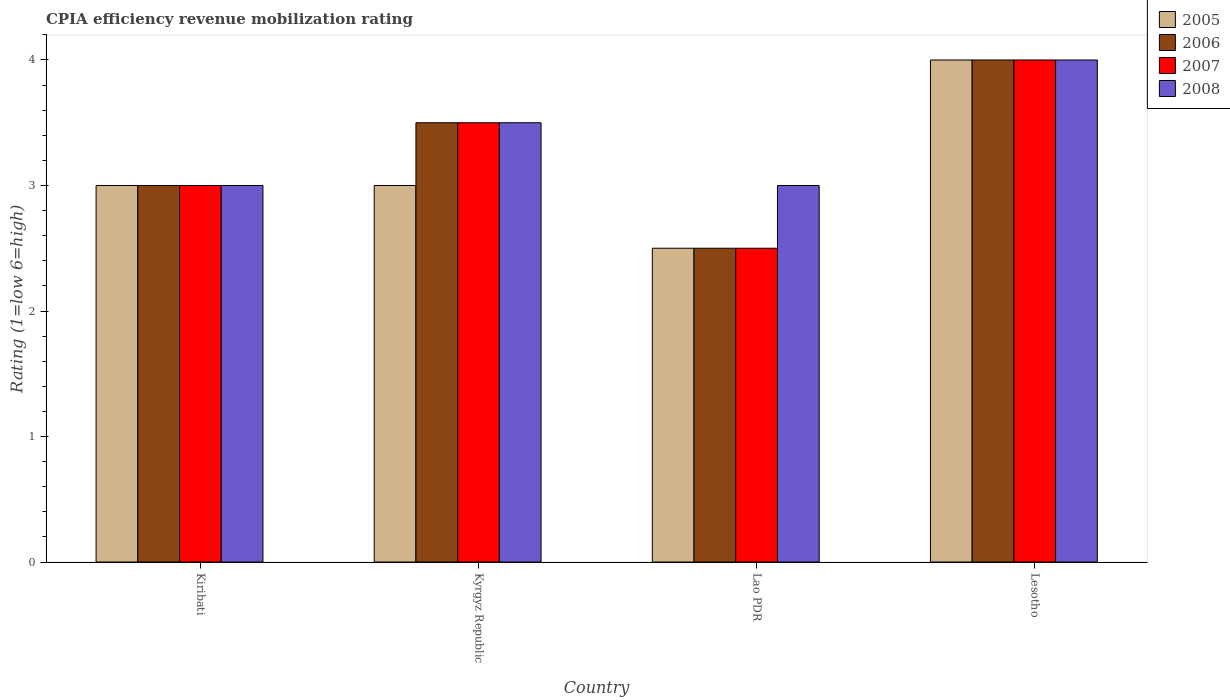How many different coloured bars are there?
Make the answer very short. 4. How many bars are there on the 1st tick from the right?
Your response must be concise. 4. What is the label of the 3rd group of bars from the left?
Provide a short and direct response. Lao PDR. In how many cases, is the number of bars for a given country not equal to the number of legend labels?
Offer a very short reply. 0. Across all countries, what is the maximum CPIA rating in 2007?
Your answer should be compact. 4. In which country was the CPIA rating in 2008 maximum?
Make the answer very short. Lesotho. In which country was the CPIA rating in 2008 minimum?
Your response must be concise. Kiribati. What is the difference between the CPIA rating in 2007 in Lao PDR and that in Lesotho?
Offer a very short reply. -1.5. What is the difference between the CPIA rating in 2008 in Kyrgyz Republic and the CPIA rating in 2006 in Lao PDR?
Ensure brevity in your answer.  1. What is the average CPIA rating in 2008 per country?
Provide a succinct answer. 3.38. What is the difference between the CPIA rating of/in 2005 and CPIA rating of/in 2008 in Lao PDR?
Provide a short and direct response. -0.5. Is the difference between the CPIA rating in 2005 in Kiribati and Lesotho greater than the difference between the CPIA rating in 2008 in Kiribati and Lesotho?
Offer a very short reply. No. What is the difference between the highest and the lowest CPIA rating in 2008?
Provide a succinct answer. 1. Is the sum of the CPIA rating in 2008 in Lao PDR and Lesotho greater than the maximum CPIA rating in 2006 across all countries?
Your answer should be compact. Yes. How many countries are there in the graph?
Your response must be concise. 4. What is the difference between two consecutive major ticks on the Y-axis?
Your response must be concise. 1. Are the values on the major ticks of Y-axis written in scientific E-notation?
Offer a very short reply. No. Does the graph contain any zero values?
Provide a short and direct response. No. Does the graph contain grids?
Provide a short and direct response. No. Where does the legend appear in the graph?
Make the answer very short. Top right. What is the title of the graph?
Your response must be concise. CPIA efficiency revenue mobilization rating. What is the label or title of the X-axis?
Provide a succinct answer. Country. What is the label or title of the Y-axis?
Your response must be concise. Rating (1=low 6=high). What is the Rating (1=low 6=high) of 2005 in Kiribati?
Your response must be concise. 3. What is the Rating (1=low 6=high) of 2006 in Kiribati?
Ensure brevity in your answer.  3. What is the Rating (1=low 6=high) of 2005 in Kyrgyz Republic?
Provide a short and direct response. 3. What is the Rating (1=low 6=high) in 2007 in Kyrgyz Republic?
Give a very brief answer. 3.5. What is the Rating (1=low 6=high) of 2008 in Kyrgyz Republic?
Keep it short and to the point. 3.5. What is the Rating (1=low 6=high) in 2006 in Lao PDR?
Your answer should be compact. 2.5. What is the Rating (1=low 6=high) of 2006 in Lesotho?
Your answer should be compact. 4. What is the Rating (1=low 6=high) in 2008 in Lesotho?
Make the answer very short. 4. Across all countries, what is the maximum Rating (1=low 6=high) in 2007?
Your response must be concise. 4. Across all countries, what is the maximum Rating (1=low 6=high) of 2008?
Your answer should be very brief. 4. Across all countries, what is the minimum Rating (1=low 6=high) in 2007?
Make the answer very short. 2.5. What is the total Rating (1=low 6=high) in 2006 in the graph?
Make the answer very short. 13. What is the total Rating (1=low 6=high) in 2008 in the graph?
Your answer should be very brief. 13.5. What is the difference between the Rating (1=low 6=high) of 2005 in Kiribati and that in Kyrgyz Republic?
Provide a short and direct response. 0. What is the difference between the Rating (1=low 6=high) of 2006 in Kiribati and that in Kyrgyz Republic?
Offer a terse response. -0.5. What is the difference between the Rating (1=low 6=high) in 2007 in Kiribati and that in Kyrgyz Republic?
Provide a short and direct response. -0.5. What is the difference between the Rating (1=low 6=high) of 2008 in Kiribati and that in Kyrgyz Republic?
Ensure brevity in your answer.  -0.5. What is the difference between the Rating (1=low 6=high) of 2006 in Kiribati and that in Lao PDR?
Ensure brevity in your answer.  0.5. What is the difference between the Rating (1=low 6=high) of 2008 in Kiribati and that in Lao PDR?
Your answer should be very brief. 0. What is the difference between the Rating (1=low 6=high) in 2007 in Kiribati and that in Lesotho?
Provide a short and direct response. -1. What is the difference between the Rating (1=low 6=high) of 2007 in Lao PDR and that in Lesotho?
Offer a very short reply. -1.5. What is the difference between the Rating (1=low 6=high) of 2008 in Lao PDR and that in Lesotho?
Offer a very short reply. -1. What is the difference between the Rating (1=low 6=high) of 2005 in Kiribati and the Rating (1=low 6=high) of 2006 in Kyrgyz Republic?
Provide a short and direct response. -0.5. What is the difference between the Rating (1=low 6=high) of 2006 in Kiribati and the Rating (1=low 6=high) of 2008 in Lao PDR?
Your response must be concise. 0. What is the difference between the Rating (1=low 6=high) of 2005 in Kiribati and the Rating (1=low 6=high) of 2007 in Lesotho?
Offer a very short reply. -1. What is the difference between the Rating (1=low 6=high) of 2005 in Kiribati and the Rating (1=low 6=high) of 2008 in Lesotho?
Your answer should be very brief. -1. What is the difference between the Rating (1=low 6=high) of 2006 in Kiribati and the Rating (1=low 6=high) of 2008 in Lesotho?
Ensure brevity in your answer.  -1. What is the difference between the Rating (1=low 6=high) of 2007 in Kiribati and the Rating (1=low 6=high) of 2008 in Lesotho?
Ensure brevity in your answer.  -1. What is the difference between the Rating (1=low 6=high) in 2005 in Kyrgyz Republic and the Rating (1=low 6=high) in 2006 in Lao PDR?
Offer a very short reply. 0.5. What is the difference between the Rating (1=low 6=high) of 2006 in Kyrgyz Republic and the Rating (1=low 6=high) of 2007 in Lao PDR?
Your response must be concise. 1. What is the difference between the Rating (1=low 6=high) in 2006 in Kyrgyz Republic and the Rating (1=low 6=high) in 2008 in Lao PDR?
Your response must be concise. 0.5. What is the difference between the Rating (1=low 6=high) of 2007 in Kyrgyz Republic and the Rating (1=low 6=high) of 2008 in Lao PDR?
Keep it short and to the point. 0.5. What is the difference between the Rating (1=low 6=high) in 2005 in Kyrgyz Republic and the Rating (1=low 6=high) in 2006 in Lesotho?
Offer a terse response. -1. What is the difference between the Rating (1=low 6=high) in 2007 in Kyrgyz Republic and the Rating (1=low 6=high) in 2008 in Lesotho?
Provide a short and direct response. -0.5. What is the difference between the Rating (1=low 6=high) in 2006 in Lao PDR and the Rating (1=low 6=high) in 2008 in Lesotho?
Offer a terse response. -1.5. What is the average Rating (1=low 6=high) in 2005 per country?
Your answer should be compact. 3.12. What is the average Rating (1=low 6=high) of 2006 per country?
Your answer should be compact. 3.25. What is the average Rating (1=low 6=high) in 2008 per country?
Your answer should be very brief. 3.38. What is the difference between the Rating (1=low 6=high) of 2005 and Rating (1=low 6=high) of 2006 in Kiribati?
Give a very brief answer. 0. What is the difference between the Rating (1=low 6=high) of 2005 and Rating (1=low 6=high) of 2007 in Kiribati?
Offer a terse response. 0. What is the difference between the Rating (1=low 6=high) of 2006 and Rating (1=low 6=high) of 2007 in Kiribati?
Your answer should be compact. 0. What is the difference between the Rating (1=low 6=high) in 2007 and Rating (1=low 6=high) in 2008 in Kiribati?
Your answer should be very brief. 0. What is the difference between the Rating (1=low 6=high) in 2007 and Rating (1=low 6=high) in 2008 in Kyrgyz Republic?
Your answer should be very brief. 0. What is the difference between the Rating (1=low 6=high) of 2006 and Rating (1=low 6=high) of 2007 in Lao PDR?
Keep it short and to the point. 0. What is the difference between the Rating (1=low 6=high) in 2007 and Rating (1=low 6=high) in 2008 in Lao PDR?
Give a very brief answer. -0.5. What is the difference between the Rating (1=low 6=high) in 2005 and Rating (1=low 6=high) in 2006 in Lesotho?
Your answer should be very brief. 0. What is the difference between the Rating (1=low 6=high) of 2005 and Rating (1=low 6=high) of 2008 in Lesotho?
Your answer should be very brief. 0. What is the difference between the Rating (1=low 6=high) in 2006 and Rating (1=low 6=high) in 2007 in Lesotho?
Your response must be concise. 0. What is the difference between the Rating (1=low 6=high) in 2006 and Rating (1=low 6=high) in 2008 in Lesotho?
Provide a short and direct response. 0. What is the difference between the Rating (1=low 6=high) in 2007 and Rating (1=low 6=high) in 2008 in Lesotho?
Make the answer very short. 0. What is the ratio of the Rating (1=low 6=high) of 2005 in Kiribati to that in Kyrgyz Republic?
Give a very brief answer. 1. What is the ratio of the Rating (1=low 6=high) in 2007 in Kiribati to that in Kyrgyz Republic?
Give a very brief answer. 0.86. What is the ratio of the Rating (1=low 6=high) of 2008 in Kiribati to that in Kyrgyz Republic?
Provide a succinct answer. 0.86. What is the ratio of the Rating (1=low 6=high) of 2006 in Kiribati to that in Lao PDR?
Ensure brevity in your answer.  1.2. What is the ratio of the Rating (1=low 6=high) of 2008 in Kiribati to that in Lao PDR?
Ensure brevity in your answer.  1. What is the ratio of the Rating (1=low 6=high) of 2006 in Kiribati to that in Lesotho?
Provide a short and direct response. 0.75. What is the ratio of the Rating (1=low 6=high) of 2005 in Kyrgyz Republic to that in Lao PDR?
Provide a short and direct response. 1.2. What is the ratio of the Rating (1=low 6=high) of 2005 in Kyrgyz Republic to that in Lesotho?
Your response must be concise. 0.75. What is the ratio of the Rating (1=low 6=high) of 2006 in Kyrgyz Republic to that in Lesotho?
Your answer should be very brief. 0.88. What is the ratio of the Rating (1=low 6=high) in 2007 in Kyrgyz Republic to that in Lesotho?
Provide a short and direct response. 0.88. What is the ratio of the Rating (1=low 6=high) of 2005 in Lao PDR to that in Lesotho?
Provide a short and direct response. 0.62. What is the ratio of the Rating (1=low 6=high) in 2006 in Lao PDR to that in Lesotho?
Provide a succinct answer. 0.62. What is the ratio of the Rating (1=low 6=high) of 2007 in Lao PDR to that in Lesotho?
Make the answer very short. 0.62. What is the difference between the highest and the second highest Rating (1=low 6=high) in 2008?
Your answer should be very brief. 0.5. What is the difference between the highest and the lowest Rating (1=low 6=high) of 2005?
Offer a very short reply. 1.5. What is the difference between the highest and the lowest Rating (1=low 6=high) in 2007?
Offer a terse response. 1.5. 